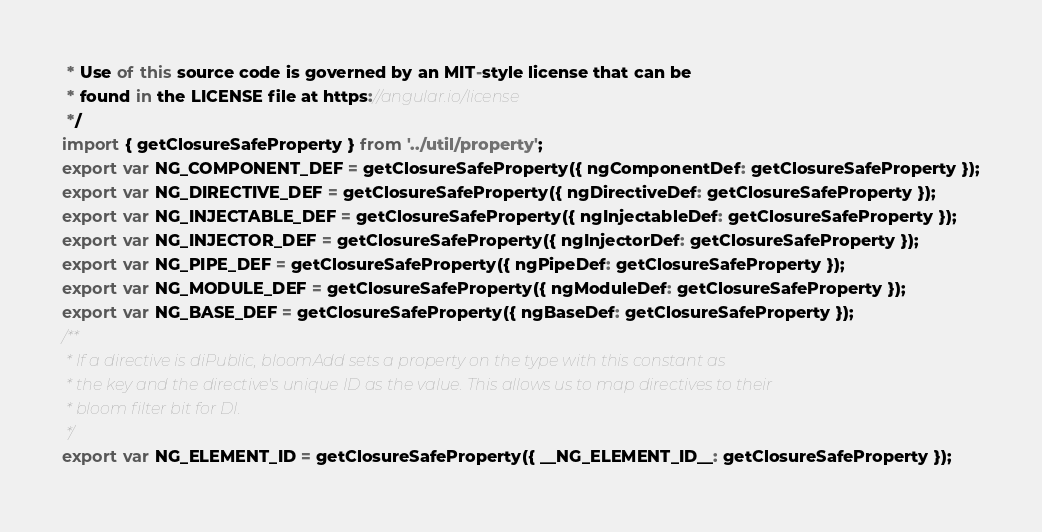<code> <loc_0><loc_0><loc_500><loc_500><_JavaScript_> * Use of this source code is governed by an MIT-style license that can be
 * found in the LICENSE file at https://angular.io/license
 */
import { getClosureSafeProperty } from '../util/property';
export var NG_COMPONENT_DEF = getClosureSafeProperty({ ngComponentDef: getClosureSafeProperty });
export var NG_DIRECTIVE_DEF = getClosureSafeProperty({ ngDirectiveDef: getClosureSafeProperty });
export var NG_INJECTABLE_DEF = getClosureSafeProperty({ ngInjectableDef: getClosureSafeProperty });
export var NG_INJECTOR_DEF = getClosureSafeProperty({ ngInjectorDef: getClosureSafeProperty });
export var NG_PIPE_DEF = getClosureSafeProperty({ ngPipeDef: getClosureSafeProperty });
export var NG_MODULE_DEF = getClosureSafeProperty({ ngModuleDef: getClosureSafeProperty });
export var NG_BASE_DEF = getClosureSafeProperty({ ngBaseDef: getClosureSafeProperty });
/**
 * If a directive is diPublic, bloomAdd sets a property on the type with this constant as
 * the key and the directive's unique ID as the value. This allows us to map directives to their
 * bloom filter bit for DI.
 */
export var NG_ELEMENT_ID = getClosureSafeProperty({ __NG_ELEMENT_ID__: getClosureSafeProperty });</code> 